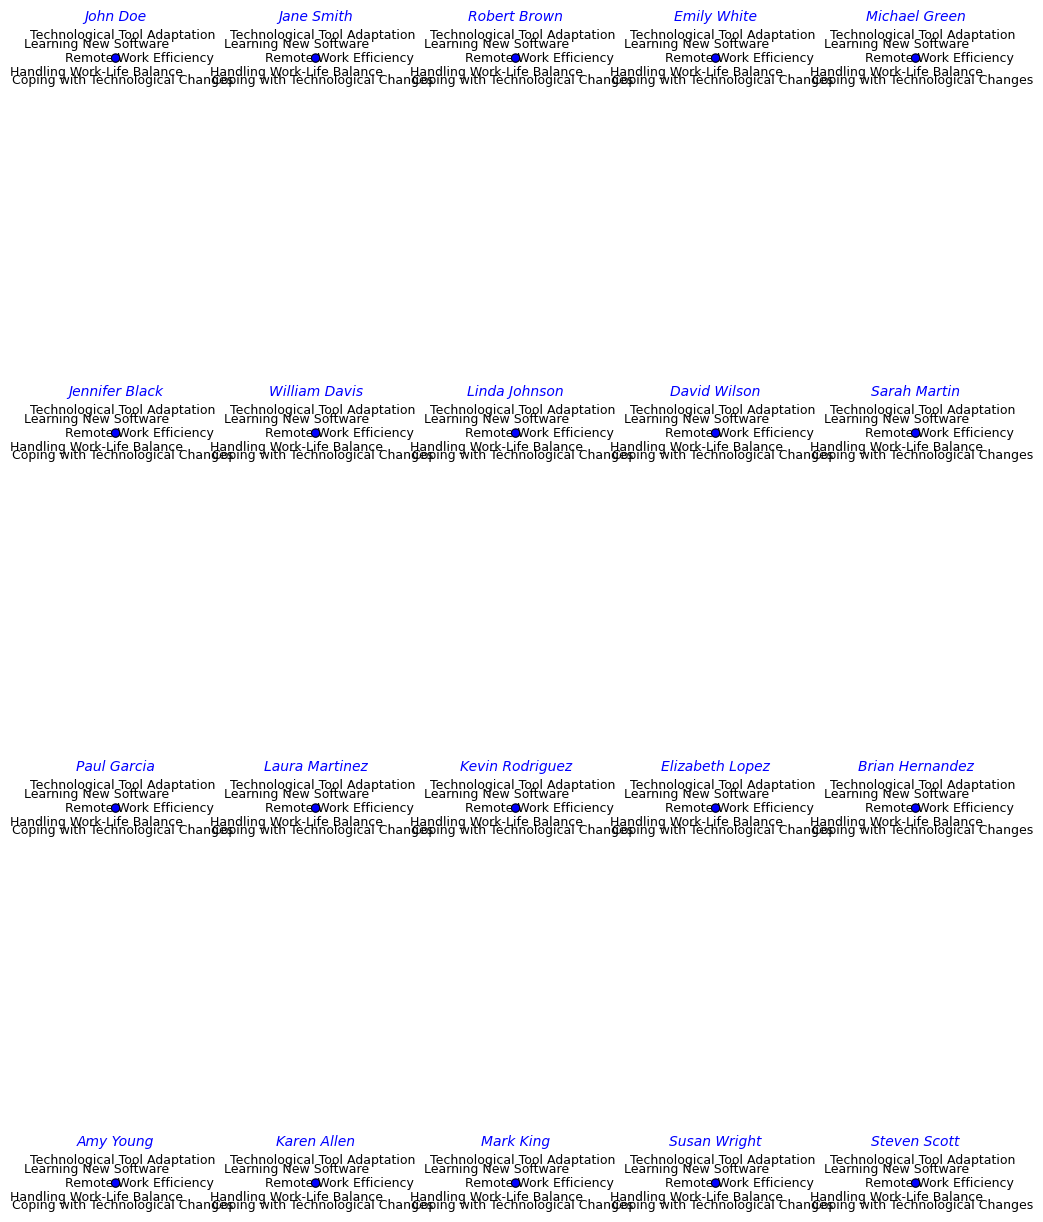Which individual has the highest score for Remote Work Efficiency? Look for the radar chart with the tallest peak for 'Remote Work Efficiency'. Robert Brown shows the highest mark.
Answer: Robert Brown How many individuals scored 90 or above in Coping with Technological Changes? Count the individuals whose radar charts hit or surpass the 90 mark for 'Coping with Technological Changes'. Five individuals (John Doe, Robert Brown, Michael Green, Kevin Rodriguez, and Brian Hernandez) scored 90 or above.
Answer: 5 Who has the lowest score in Handling Work-Life Balance, and what is this score? Identify the radar chart with the shortest radius for 'Handling Work-Life Balance'. Jennifer Black has the lowest score of 60.
Answer: Jennifer Black, 60 Who has better overall scores in Remote Work Efficiency, Emily White or Linda Johnson? Compare the 'Remote Work Efficiency' scores of Emily White and Linda Johnson. Emily White scores 75, while Linda Johnson scores 85. Linda Johnson has a better score.
Answer: Linda Johnson What is the average score for the Learning New Software dimension? Sum up all the 'Learning New Software' scores and divide by the number of individuals (20). The sum is: 78 + 77 + 83 + 85 + 82 + 80 + 76 + 79 + 81 + 78 + 84 + 87 + 82 + 82 + 83 + 79 + 88 + 81 + 79 + 82 = 1629. The average is 1629/20 = 81.45.
Answer: 81.45 Which individual has the most balanced scores across all dimensions? Find the radar chart with relatively even distances in all five axes. Karen Allen appears the most balanced with scores: Remote Work Efficiency (87), Technological Tool Adaptation (89), Learning New Software (88), Handling Work-Life Balance (81), Coping with Technological Changes (91).
Answer: Karen Allen Do more individuals score higher than 80 in Remote Work Efficiency or Technological Tool Adaptation? Count how many individuals score higher than 80 in each dimension. For Remote Work Efficiency: Jane Smith, Robert Brown, Michael Green, Linda Johnson, Kevin Rodriguez, David Wilson, Sarah Martin, Elizabeth Lopez, Brian Hernandez, Karen Allen, Steven Scott (11 individuals). For Technological Tool Adaptation: John Doe, Jane Smith, Robert Brown, Michael Green, William Davis, Linda Johnson, David Wilson, Sarah Martin, Paul Garcia, Kevin Rodriguez, Brian Hernandez, Karen Allen, Steven Scott (13 individuals). Technological Tool Adaptation has more.
Answer: Technological Tool Adaptation Compare the average scores of men and women in Handling Work-Life Balance. Separate the scores by gender and calculate their averages. Men: (65 + 80 + 85 + 68 + 75 + 68 + 72 + 75 + 80 + 73 + 69 + 77) / 12 = 71. Men's average for Handling Work-Life Balance is 73.04. Women: (75 + 70 + 60 + 74 + 81 + 76 + 68 + 65) / 8 = 71. Women's average for Handling Work-Life Balance is 70.87.
Answer: Men: 73.04, Women: 70.87 